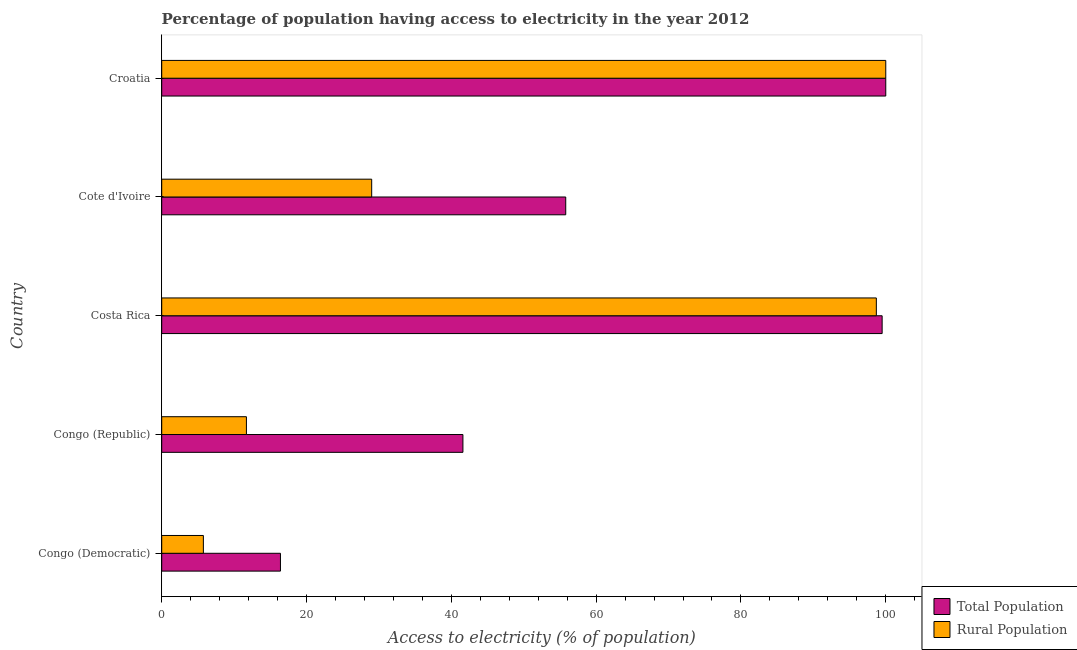How many groups of bars are there?
Offer a terse response. 5. Are the number of bars per tick equal to the number of legend labels?
Provide a succinct answer. Yes. Are the number of bars on each tick of the Y-axis equal?
Make the answer very short. Yes. How many bars are there on the 3rd tick from the top?
Offer a terse response. 2. What is the label of the 5th group of bars from the top?
Provide a succinct answer. Congo (Democratic). In how many cases, is the number of bars for a given country not equal to the number of legend labels?
Keep it short and to the point. 0. What is the percentage of rural population having access to electricity in Costa Rica?
Provide a succinct answer. 98.7. Across all countries, what is the minimum percentage of rural population having access to electricity?
Your response must be concise. 5.75. In which country was the percentage of rural population having access to electricity maximum?
Ensure brevity in your answer.  Croatia. In which country was the percentage of population having access to electricity minimum?
Your answer should be compact. Congo (Democratic). What is the total percentage of population having access to electricity in the graph?
Provide a short and direct response. 313.3. What is the difference between the percentage of rural population having access to electricity in Congo (Republic) and that in Cote d'Ivoire?
Provide a short and direct response. -17.3. What is the difference between the percentage of population having access to electricity in Croatia and the percentage of rural population having access to electricity in Congo (Democratic)?
Provide a succinct answer. 94.25. What is the average percentage of population having access to electricity per country?
Offer a terse response. 62.66. What is the difference between the percentage of population having access to electricity and percentage of rural population having access to electricity in Congo (Republic)?
Give a very brief answer. 29.9. What is the difference between the highest and the lowest percentage of rural population having access to electricity?
Give a very brief answer. 94.25. Is the sum of the percentage of rural population having access to electricity in Congo (Democratic) and Congo (Republic) greater than the maximum percentage of population having access to electricity across all countries?
Your response must be concise. No. What does the 2nd bar from the top in Congo (Republic) represents?
Make the answer very short. Total Population. What does the 1st bar from the bottom in Cote d'Ivoire represents?
Keep it short and to the point. Total Population. How many countries are there in the graph?
Offer a terse response. 5. Where does the legend appear in the graph?
Offer a terse response. Bottom right. What is the title of the graph?
Ensure brevity in your answer.  Percentage of population having access to electricity in the year 2012. What is the label or title of the X-axis?
Offer a terse response. Access to electricity (% of population). What is the Access to electricity (% of population) in Total Population in Congo (Democratic)?
Offer a terse response. 16.4. What is the Access to electricity (% of population) in Rural Population in Congo (Democratic)?
Your answer should be compact. 5.75. What is the Access to electricity (% of population) in Total Population in Congo (Republic)?
Provide a short and direct response. 41.6. What is the Access to electricity (% of population) in Rural Population in Congo (Republic)?
Give a very brief answer. 11.7. What is the Access to electricity (% of population) of Total Population in Costa Rica?
Offer a terse response. 99.5. What is the Access to electricity (% of population) of Rural Population in Costa Rica?
Your answer should be compact. 98.7. What is the Access to electricity (% of population) of Total Population in Cote d'Ivoire?
Provide a succinct answer. 55.8. What is the Access to electricity (% of population) of Rural Population in Cote d'Ivoire?
Offer a very short reply. 29. Across all countries, what is the maximum Access to electricity (% of population) in Total Population?
Provide a succinct answer. 100. Across all countries, what is the minimum Access to electricity (% of population) in Total Population?
Keep it short and to the point. 16.4. Across all countries, what is the minimum Access to electricity (% of population) of Rural Population?
Make the answer very short. 5.75. What is the total Access to electricity (% of population) of Total Population in the graph?
Keep it short and to the point. 313.3. What is the total Access to electricity (% of population) in Rural Population in the graph?
Offer a very short reply. 245.15. What is the difference between the Access to electricity (% of population) in Total Population in Congo (Democratic) and that in Congo (Republic)?
Give a very brief answer. -25.2. What is the difference between the Access to electricity (% of population) in Rural Population in Congo (Democratic) and that in Congo (Republic)?
Offer a very short reply. -5.95. What is the difference between the Access to electricity (% of population) of Total Population in Congo (Democratic) and that in Costa Rica?
Make the answer very short. -83.1. What is the difference between the Access to electricity (% of population) in Rural Population in Congo (Democratic) and that in Costa Rica?
Provide a short and direct response. -92.95. What is the difference between the Access to electricity (% of population) of Total Population in Congo (Democratic) and that in Cote d'Ivoire?
Ensure brevity in your answer.  -39.4. What is the difference between the Access to electricity (% of population) in Rural Population in Congo (Democratic) and that in Cote d'Ivoire?
Offer a terse response. -23.25. What is the difference between the Access to electricity (% of population) of Total Population in Congo (Democratic) and that in Croatia?
Offer a very short reply. -83.6. What is the difference between the Access to electricity (% of population) in Rural Population in Congo (Democratic) and that in Croatia?
Keep it short and to the point. -94.25. What is the difference between the Access to electricity (% of population) in Total Population in Congo (Republic) and that in Costa Rica?
Give a very brief answer. -57.9. What is the difference between the Access to electricity (% of population) in Rural Population in Congo (Republic) and that in Costa Rica?
Give a very brief answer. -87. What is the difference between the Access to electricity (% of population) of Rural Population in Congo (Republic) and that in Cote d'Ivoire?
Your answer should be compact. -17.3. What is the difference between the Access to electricity (% of population) of Total Population in Congo (Republic) and that in Croatia?
Offer a very short reply. -58.4. What is the difference between the Access to electricity (% of population) in Rural Population in Congo (Republic) and that in Croatia?
Provide a succinct answer. -88.3. What is the difference between the Access to electricity (% of population) in Total Population in Costa Rica and that in Cote d'Ivoire?
Offer a terse response. 43.7. What is the difference between the Access to electricity (% of population) in Rural Population in Costa Rica and that in Cote d'Ivoire?
Provide a succinct answer. 69.7. What is the difference between the Access to electricity (% of population) of Total Population in Cote d'Ivoire and that in Croatia?
Make the answer very short. -44.2. What is the difference between the Access to electricity (% of population) of Rural Population in Cote d'Ivoire and that in Croatia?
Your answer should be compact. -71. What is the difference between the Access to electricity (% of population) of Total Population in Congo (Democratic) and the Access to electricity (% of population) of Rural Population in Costa Rica?
Provide a succinct answer. -82.3. What is the difference between the Access to electricity (% of population) of Total Population in Congo (Democratic) and the Access to electricity (% of population) of Rural Population in Croatia?
Provide a short and direct response. -83.6. What is the difference between the Access to electricity (% of population) of Total Population in Congo (Republic) and the Access to electricity (% of population) of Rural Population in Costa Rica?
Your response must be concise. -57.1. What is the difference between the Access to electricity (% of population) in Total Population in Congo (Republic) and the Access to electricity (% of population) in Rural Population in Cote d'Ivoire?
Provide a succinct answer. 12.6. What is the difference between the Access to electricity (% of population) in Total Population in Congo (Republic) and the Access to electricity (% of population) in Rural Population in Croatia?
Your response must be concise. -58.4. What is the difference between the Access to electricity (% of population) of Total Population in Costa Rica and the Access to electricity (% of population) of Rural Population in Cote d'Ivoire?
Your answer should be compact. 70.5. What is the difference between the Access to electricity (% of population) in Total Population in Cote d'Ivoire and the Access to electricity (% of population) in Rural Population in Croatia?
Your answer should be compact. -44.2. What is the average Access to electricity (% of population) in Total Population per country?
Your response must be concise. 62.66. What is the average Access to electricity (% of population) of Rural Population per country?
Provide a short and direct response. 49.03. What is the difference between the Access to electricity (% of population) of Total Population and Access to electricity (% of population) of Rural Population in Congo (Democratic)?
Make the answer very short. 10.65. What is the difference between the Access to electricity (% of population) in Total Population and Access to electricity (% of population) in Rural Population in Congo (Republic)?
Make the answer very short. 29.9. What is the difference between the Access to electricity (% of population) in Total Population and Access to electricity (% of population) in Rural Population in Cote d'Ivoire?
Your response must be concise. 26.8. What is the ratio of the Access to electricity (% of population) in Total Population in Congo (Democratic) to that in Congo (Republic)?
Give a very brief answer. 0.39. What is the ratio of the Access to electricity (% of population) in Rural Population in Congo (Democratic) to that in Congo (Republic)?
Your answer should be very brief. 0.49. What is the ratio of the Access to electricity (% of population) in Total Population in Congo (Democratic) to that in Costa Rica?
Your response must be concise. 0.16. What is the ratio of the Access to electricity (% of population) in Rural Population in Congo (Democratic) to that in Costa Rica?
Provide a short and direct response. 0.06. What is the ratio of the Access to electricity (% of population) of Total Population in Congo (Democratic) to that in Cote d'Ivoire?
Provide a short and direct response. 0.29. What is the ratio of the Access to electricity (% of population) in Rural Population in Congo (Democratic) to that in Cote d'Ivoire?
Provide a succinct answer. 0.2. What is the ratio of the Access to electricity (% of population) of Total Population in Congo (Democratic) to that in Croatia?
Your answer should be very brief. 0.16. What is the ratio of the Access to electricity (% of population) of Rural Population in Congo (Democratic) to that in Croatia?
Keep it short and to the point. 0.06. What is the ratio of the Access to electricity (% of population) of Total Population in Congo (Republic) to that in Costa Rica?
Ensure brevity in your answer.  0.42. What is the ratio of the Access to electricity (% of population) of Rural Population in Congo (Republic) to that in Costa Rica?
Your answer should be compact. 0.12. What is the ratio of the Access to electricity (% of population) in Total Population in Congo (Republic) to that in Cote d'Ivoire?
Keep it short and to the point. 0.75. What is the ratio of the Access to electricity (% of population) of Rural Population in Congo (Republic) to that in Cote d'Ivoire?
Offer a terse response. 0.4. What is the ratio of the Access to electricity (% of population) in Total Population in Congo (Republic) to that in Croatia?
Ensure brevity in your answer.  0.42. What is the ratio of the Access to electricity (% of population) in Rural Population in Congo (Republic) to that in Croatia?
Offer a very short reply. 0.12. What is the ratio of the Access to electricity (% of population) of Total Population in Costa Rica to that in Cote d'Ivoire?
Give a very brief answer. 1.78. What is the ratio of the Access to electricity (% of population) in Rural Population in Costa Rica to that in Cote d'Ivoire?
Provide a short and direct response. 3.4. What is the ratio of the Access to electricity (% of population) of Total Population in Costa Rica to that in Croatia?
Provide a succinct answer. 0.99. What is the ratio of the Access to electricity (% of population) of Total Population in Cote d'Ivoire to that in Croatia?
Provide a short and direct response. 0.56. What is the ratio of the Access to electricity (% of population) in Rural Population in Cote d'Ivoire to that in Croatia?
Your response must be concise. 0.29. What is the difference between the highest and the lowest Access to electricity (% of population) of Total Population?
Provide a succinct answer. 83.6. What is the difference between the highest and the lowest Access to electricity (% of population) of Rural Population?
Your answer should be compact. 94.25. 